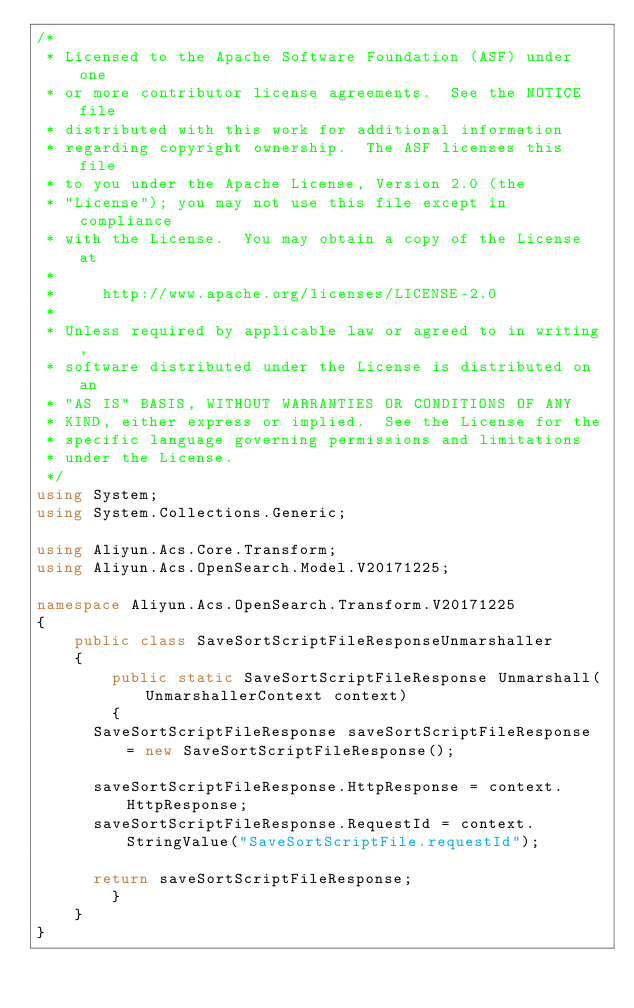Convert code to text. <code><loc_0><loc_0><loc_500><loc_500><_C#_>/*
 * Licensed to the Apache Software Foundation (ASF) under one
 * or more contributor license agreements.  See the NOTICE file
 * distributed with this work for additional information
 * regarding copyright ownership.  The ASF licenses this file
 * to you under the Apache License, Version 2.0 (the
 * "License"); you may not use this file except in compliance
 * with the License.  You may obtain a copy of the License at
 *
 *     http://www.apache.org/licenses/LICENSE-2.0
 *
 * Unless required by applicable law or agreed to in writing,
 * software distributed under the License is distributed on an
 * "AS IS" BASIS, WITHOUT WARRANTIES OR CONDITIONS OF ANY
 * KIND, either express or implied.  See the License for the
 * specific language governing permissions and limitations
 * under the License.
 */
using System;
using System.Collections.Generic;

using Aliyun.Acs.Core.Transform;
using Aliyun.Acs.OpenSearch.Model.V20171225;

namespace Aliyun.Acs.OpenSearch.Transform.V20171225
{
    public class SaveSortScriptFileResponseUnmarshaller
    {
        public static SaveSortScriptFileResponse Unmarshall(UnmarshallerContext context)
        {
			SaveSortScriptFileResponse saveSortScriptFileResponse = new SaveSortScriptFileResponse();

			saveSortScriptFileResponse.HttpResponse = context.HttpResponse;
			saveSortScriptFileResponse.RequestId = context.StringValue("SaveSortScriptFile.requestId");
        
			return saveSortScriptFileResponse;
        }
    }
}
</code> 